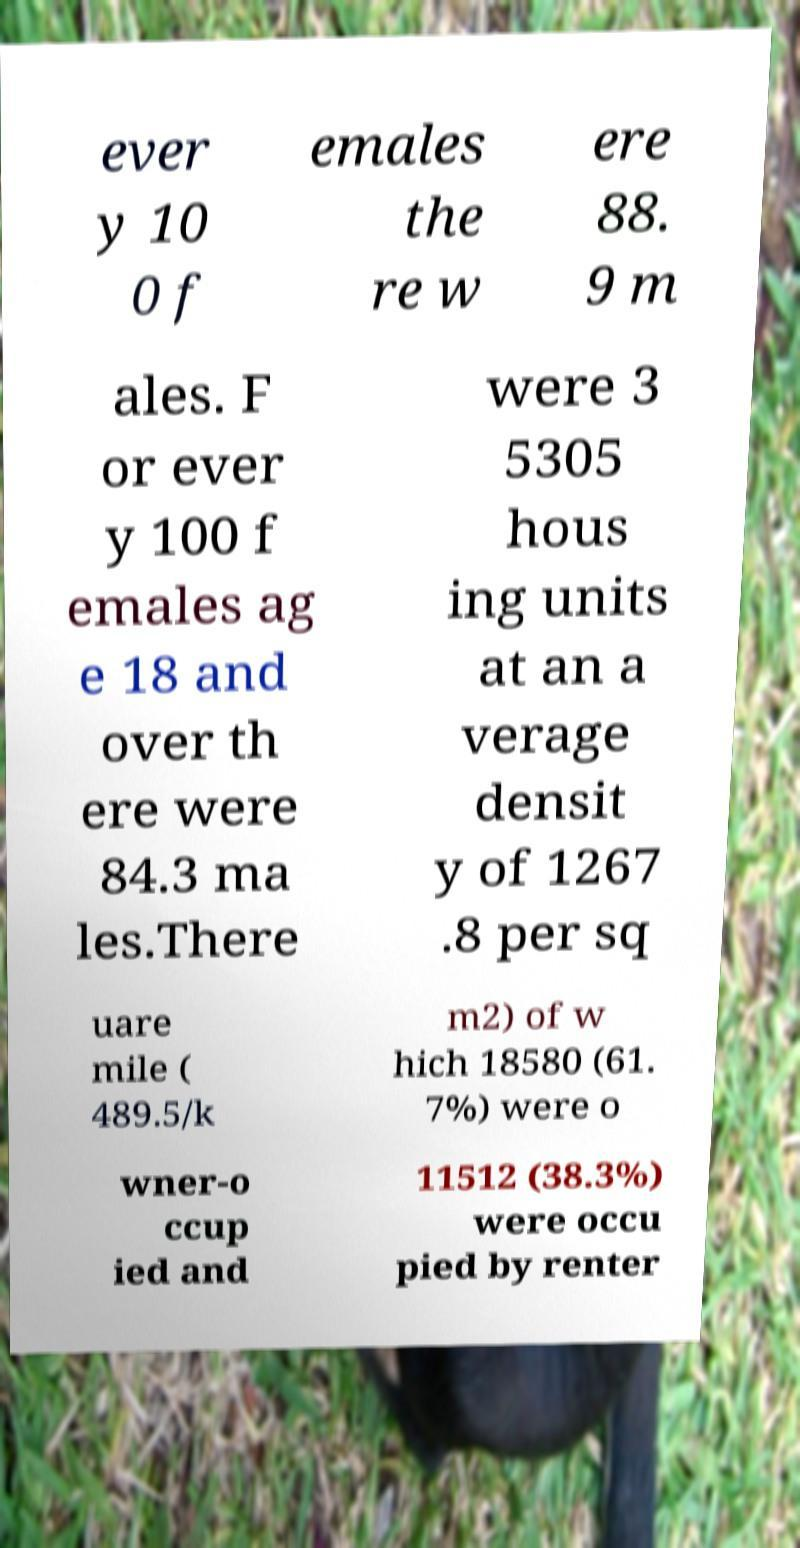For documentation purposes, I need the text within this image transcribed. Could you provide that? ever y 10 0 f emales the re w ere 88. 9 m ales. F or ever y 100 f emales ag e 18 and over th ere were 84.3 ma les.There were 3 5305 hous ing units at an a verage densit y of 1267 .8 per sq uare mile ( 489.5/k m2) of w hich 18580 (61. 7%) were o wner-o ccup ied and 11512 (38.3%) were occu pied by renter 